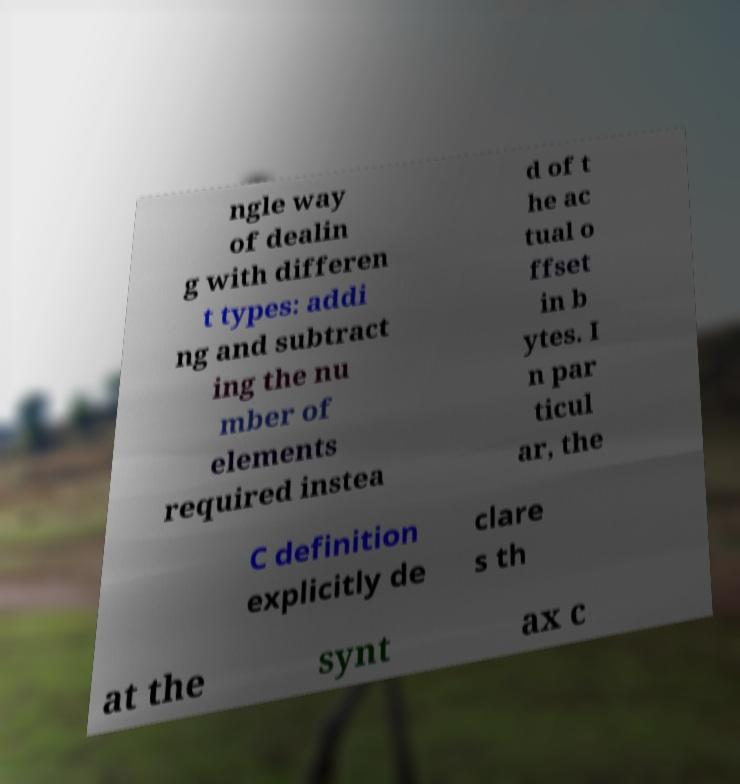Please identify and transcribe the text found in this image. ngle way of dealin g with differen t types: addi ng and subtract ing the nu mber of elements required instea d of t he ac tual o ffset in b ytes. I n par ticul ar, the C definition explicitly de clare s th at the synt ax c 